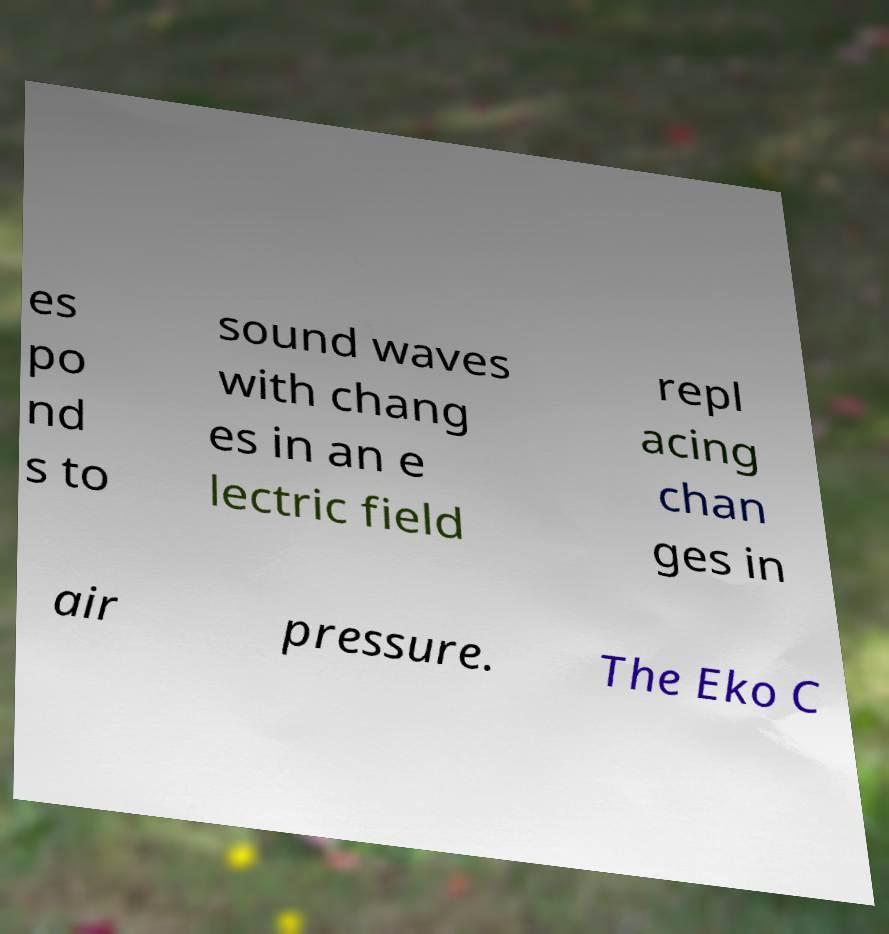Please identify and transcribe the text found in this image. es po nd s to sound waves with chang es in an e lectric field repl acing chan ges in air pressure. The Eko C 